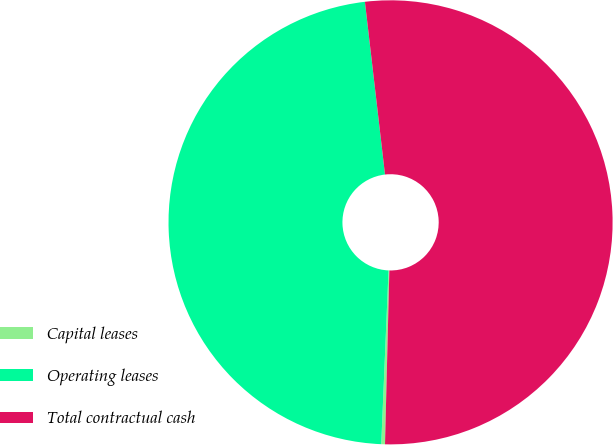Convert chart to OTSL. <chart><loc_0><loc_0><loc_500><loc_500><pie_chart><fcel>Capital leases<fcel>Operating leases<fcel>Total contractual cash<nl><fcel>0.27%<fcel>47.49%<fcel>52.24%<nl></chart> 